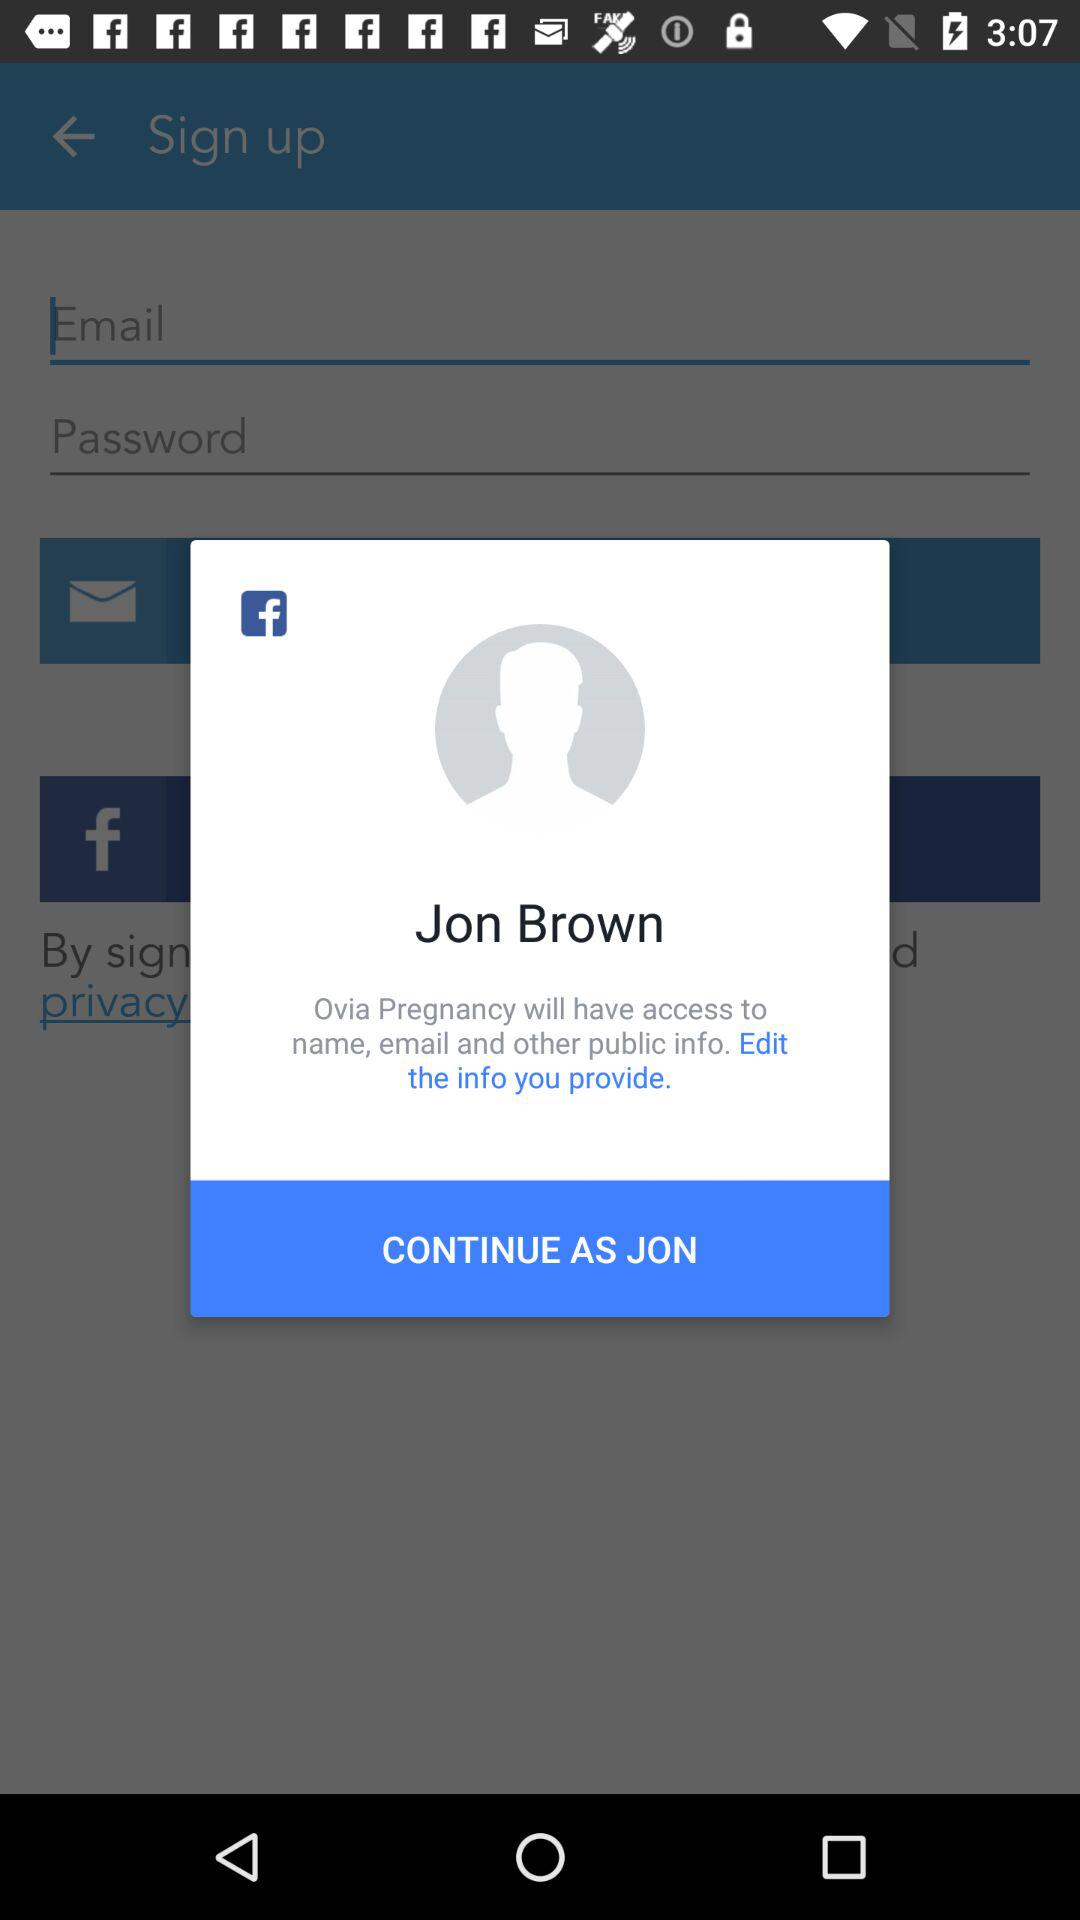What is the name of Facebook user? The name of the user is Jon Brown. 